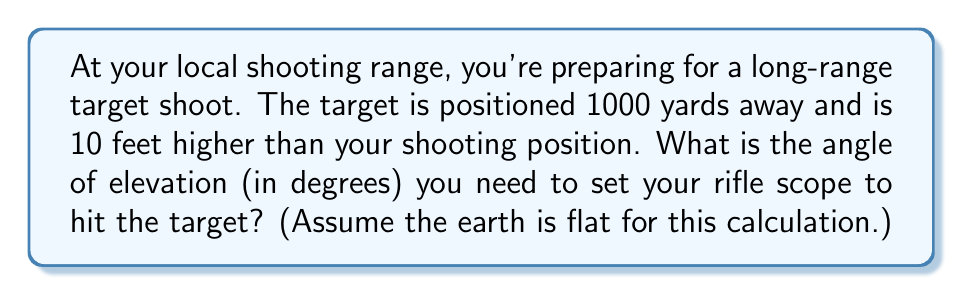Help me with this question. Let's approach this step-by-step:

1) First, we need to visualize the problem. We have a right triangle where:
   - The base (horizontal distance) is 1000 yards
   - The height difference is 10 feet

2) We need to convert all measurements to the same unit. Let's use feet:
   - 1000 yards = 3000 feet (1 yard = 3 feet)
   - The height remains 10 feet

3) Now we can set up our triangle:

[asy]
unitsize(0.1 inch);
draw((0,0)--(300,0)--(300,10)--(0,0),black);
label("3000 ft", (150,-5), S);
label("10 ft", (305,5), E);
label("θ", (5,5), NW);
[/asy]

4) We need to find the angle θ. In a right triangle, we can use the tangent function:

   $$\tan(\theta) = \frac{\text{opposite}}{\text{adjacent}} = \frac{\text{height}}{\text{base}}$$

5) Plugging in our values:

   $$\tan(\theta) = \frac{10}{3000} = \frac{1}{300}$$

6) To find θ, we need to use the inverse tangent (arctan or tan^(-1)):

   $$\theta = \tan^{-1}(\frac{1}{300})$$

7) Using a calculator (or a trig table for those who prefer):

   $$\theta \approx 0.19107 \text{ radians}$$

8) Convert radians to degrees:

   $$\theta \approx 0.19107 \times \frac{180}{\pi} \approx 10.95 \text{ degrees}$$
Answer: The angle of elevation needed is approximately $0.19107$ radians or $10.95$ degrees. 